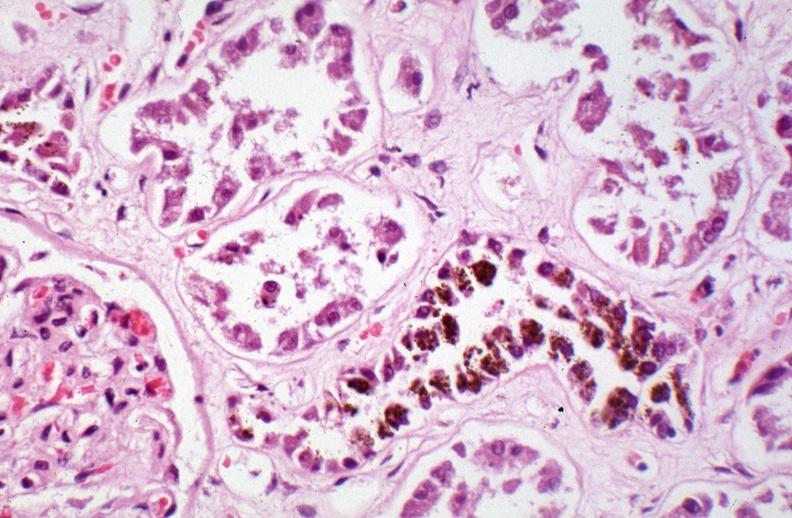how is hemosiderosis caused by blood transfusions?
Answer the question using a single word or phrase. Numerous 